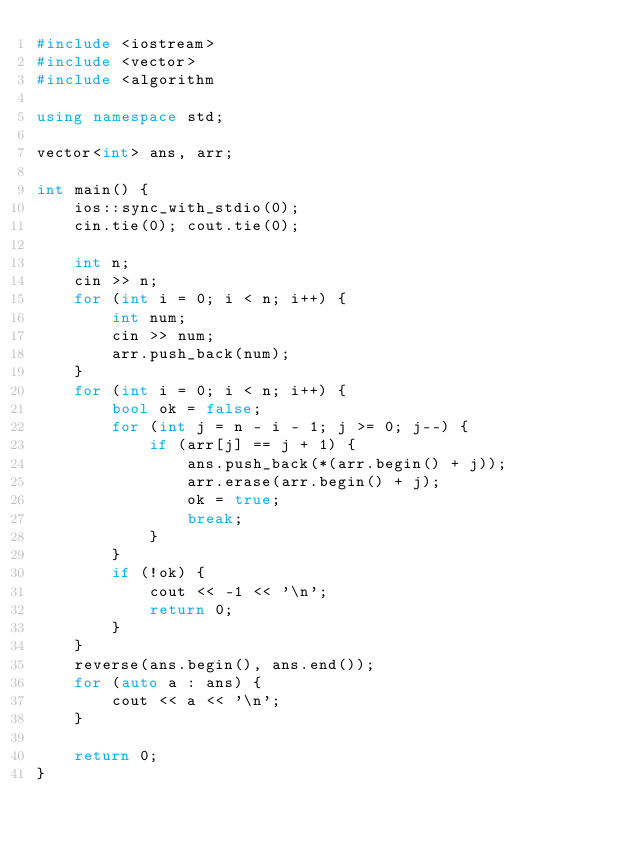Convert code to text. <code><loc_0><loc_0><loc_500><loc_500><_C++_>#include <iostream>
#include <vector>
#include <algorithm

using namespace std;

vector<int> ans, arr;

int main() {
    ios::sync_with_stdio(0);
    cin.tie(0); cout.tie(0);

    int n;
    cin >> n;
    for (int i = 0; i < n; i++) {
        int num;
        cin >> num;
        arr.push_back(num);
    }
    for (int i = 0; i < n; i++) {
        bool ok = false;
        for (int j = n - i - 1; j >= 0; j--) {
            if (arr[j] == j + 1) {
                ans.push_back(*(arr.begin() + j));
                arr.erase(arr.begin() + j);
                ok = true;
                break;
            }
        }
        if (!ok) {
            cout << -1 << '\n';
            return 0;
        }
    }
    reverse(ans.begin(), ans.end());
    for (auto a : ans) {
        cout << a << '\n';
    }

    return 0;
}</code> 